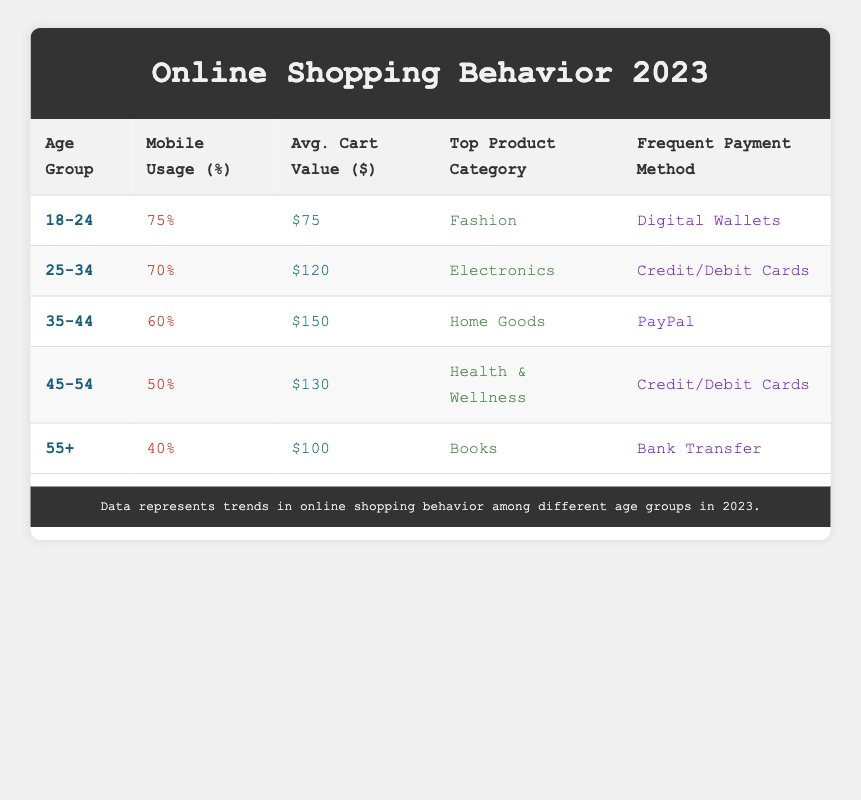What percentage of the 18-24 age group uses mobile for online shopping? The table indicates that for the 18-24 age group, the percentage using mobile is directly listed in the "Mobile Usage" column, which shows 75%.
Answer: 75% Which age group has the highest average cart value? To find this, we compare the "Avg. Cart Value" values across the age groups. The 35-44 age group has the highest value listed at $150.
Answer: 35-44 Is "Health & Wellness" the top product category for the 25-34 age group? The "Top Product Category" for the 25-34 age group in the table is "Electronics," not "Health & Wellness," so this statement is false.
Answer: No What is the average cart value among the age groups of 45-54 and 55+? The average cart value for the 45-54 age group is $130, and for 55+ it is $100. To find the average, we sum these values (130 + 100) = 230 and divide by 2, giving us 230/2 = 115.
Answer: 115 Does the percentage of mobile users decrease consistently with increasing age? We examine the "Mobile Usage" percentages: 75%, 70%, 60%, 50%, and 40% respectively. Since each age group has a lower percentage than the previous one, the answer is yes.
Answer: Yes Which payment method is most popular among the 35-44 age group? The table shows that for the 35-44 age group, the frequent payment method is listed as "PayPal," providing a straightforward answer.
Answer: PayPal What is the combined percentage of mobile usage for the 18-24 and 25-34 age groups? We take the mobile usage percentages for both age groups: 75% for 18-24 and 70% for 25-34. Adding them gives us a total of 75 + 70 = 145%.
Answer: 145% Based on the data, how much higher is the average cart value for the 35-44 age group compared to the 55+ age group? The average cart value for 35-44 is $150, while for 55+ it is $100. To find the difference: 150 - 100 = 50.
Answer: 50 Are digital wallets preferred by more than 60% of mobile users in any age group? The table shows that 75% of users in the 18-24 age group use mobile and favor digital wallets, which confirms that yes, it is indeed preferred by more than 60%.
Answer: Yes 